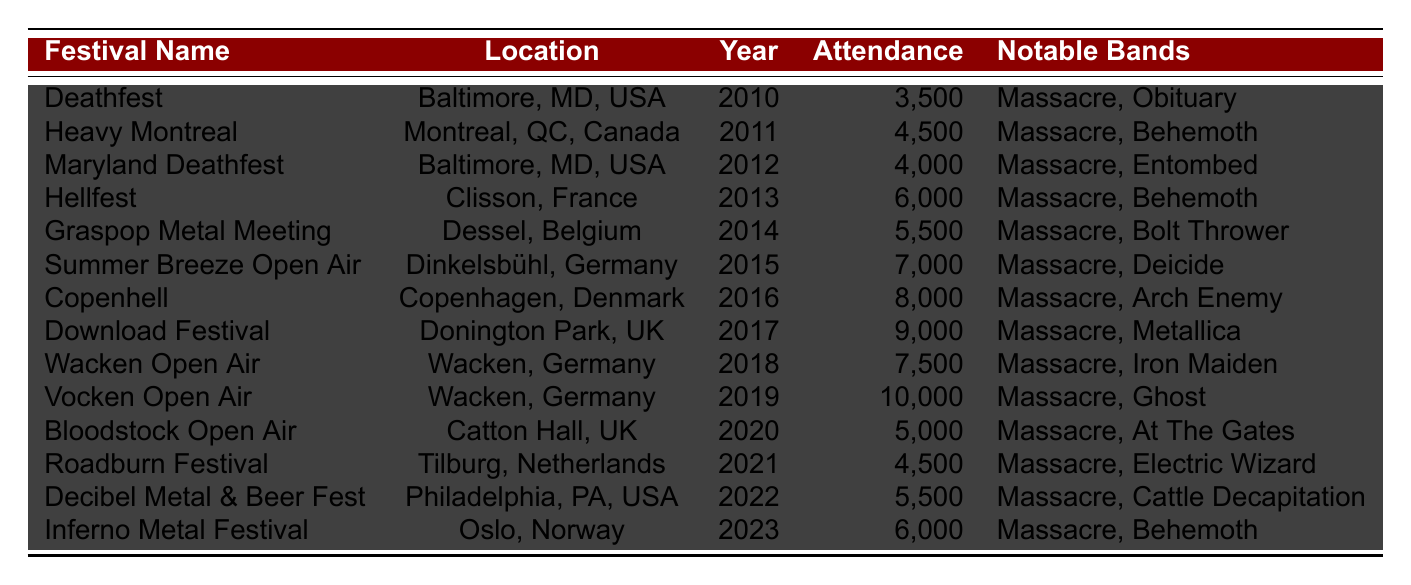What was the highest attendance at a Death Metal festival between 2010 and 2023? The attendance figures are listed for each festival. The highest value is 10,000 for the Vocken Open Air in 2019.
Answer: 10,000 Which festival had the lowest attendance? By examining the table, the lowest attendance is 3,500 at Deathfest in 2010.
Answer: 3,500 In which year did the attendance reach 9,000? The table shows that the attendance reached 9,000 in the year 2017 during the Download Festival.
Answer: 2017 How many festivals took place in the USA? The table lists three festivals located in the USA: Deathfest (2010), Maryland Deathfest (2012), and Decibel Metal & Beer Fest (2022), making a total of 3.
Answer: 3 What is the total attendance for festivals in Wacken, Germany? The table shows two festivals in Wacken: Wacken Open Air (2018) with 7,500 attendees and Vocken Open Air (2019) with 10,000. Adding these gives us 7,500 + 10,000 = 17,500.
Answer: 17,500 Was Massacre part of the lineup for the Heavy Montreal festival? Yes, the table indicates that Massacre was part of the lineup for Heavy Montreal in 2011.
Answer: Yes What is the average attendance of all the festivals that had Massacre in their lineup? The attendances for the festivals featuring Massacre are: 3,500, 4,500, 4,000, 6,000, 5,500, 7,000, 8,000, 9,000, 7,500, 10,000, 5,000, 4,500, 5,500, 6,000. Summing these gives 3,500 + 4,500 + 4,000 + 6,000 + 5,500 + 7,000 + 8,000 + 9,000 + 7,500 + 10,000 + 5,000 + 4,500 + 5,500 + 6,000 = 81,000. There are 14 festivals, so the average is 81,000 / 14 ≈ 5,785.71.
Answer: 5,785.71 Which festival featured Metallica in its lineup? The Download Festival in 2017 included Metallica in its lineup.
Answer: Download Festival How many festivals experienced attendance over 7,000? By examining the table, the festivals with attendance over 7,000 are Summer Breeze Open Air (2015), Copenhell (2016), Download Festival (2017), Wacken Open Air (2018), Vocken Open Air (2019), totaling 5 festivals.
Answer: 5 What festival had Massacre and Behemoth in their lineup and what was its attendance? The Hellfest in 2013 had both Massacre and Behemoth in the lineup, with an attendance of 6,000.
Answer: Hellfest, 6,000 